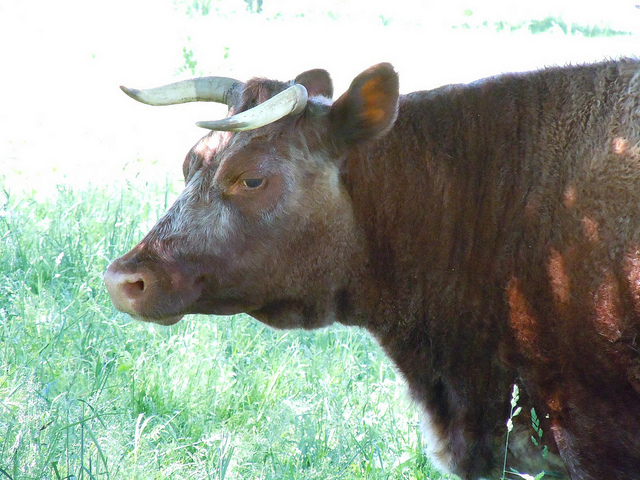What's the significance of the Longhorn in history or culture? The Longhorn has become an enduring symbol of the Old West, representing the era of cattle drives and cowboys. In the 19th century, they were a major economic asset in the Texas livestock industry. Today, they are celebrated for their hardiness and the cultural heritage they represent, often associated with the spirit of independence and strength. 